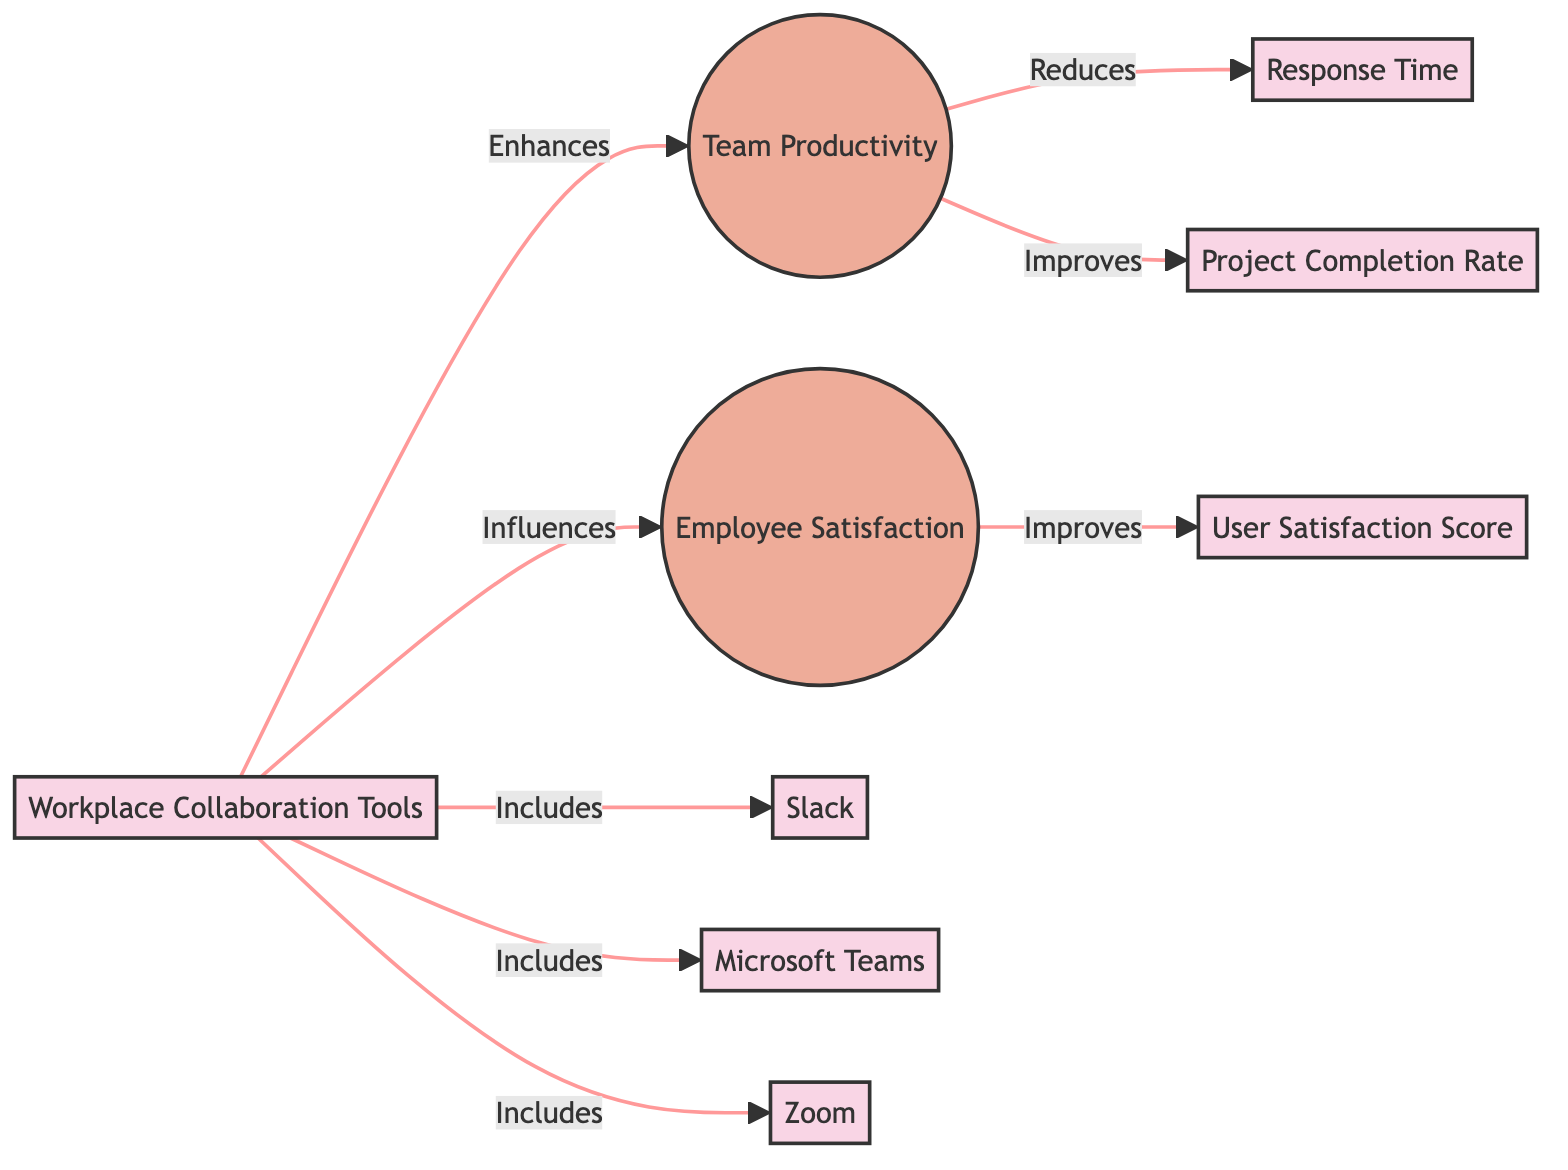What are the three tools included in workplace collaboration tools? The diagram lists Slack, Microsoft Teams, and Zoom as the workplace collaboration tools. These tools are visually connected to the collaboration tools node, indicating they are components of that category.
Answer: Slack, Microsoft Teams, Zoom How many main nodes are in the diagram? The diagram consists of seven main nodes in total: five are specific terms (collaboration tools, team productivity, employee satisfaction, response time, project completion rate, user satisfaction score), and the three collaboration tools listed above. Therefore, adding them gives a total of seven.
Answer: Seven What effect does workplace collaboration tools have on team productivity? According to the diagram, workplace collaboration tools enhance team productivity, showing a direct influence from the collaboration tools to team productivity node.
Answer: Enhances What relationship exists between team productivity and response time? The diagram indicates that team productivity reduces response time, establishing a causal relationship from team productivity to response time.
Answer: Reduces Which metric improves with employee satisfaction according to the diagram? The diagram reveals that user satisfaction score improves with employee satisfaction, indicating a positive connection from employee satisfaction to user satisfaction score.
Answer: User Satisfaction Score What is influenced by workplace collaboration tools besides employee satisfaction? The diagram explicitly states that workplace collaboration tools also enhance team productivity. This shows that collaboration tools are not limited in their positive effects and influence both aspects mentioned in the diagram.
Answer: Team Productivity What type of node is 'employee satisfaction'? The diagram visually categorizes employee satisfaction as an ellipse, distinguished from the rectangle nodes that represent different metrics and tools.
Answer: Ellipse How many edges connect to the node 'collaboration tools'? Upon reviewing the diagram, the node labeled 'collaboration tools' has four edges leading to other nodes, indicating its connections to various aspects like team productivity and employee satisfaction, plus connections to individual tools.
Answer: Four What decreases as team productivity improves? The diagram shows that response time decreases as team productivity improves, establishing a direct connection between these two nodes.
Answer: Response Time 